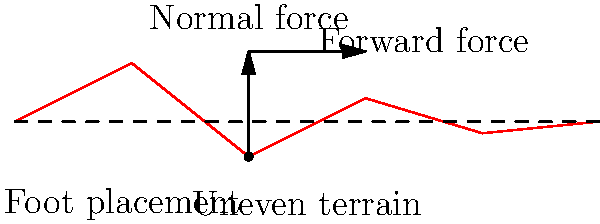When walking on uneven historical site terrain, as shown in the diagram, which biomechanical adaptation is most crucial for maintaining balance and preventing falls? To understand the biomechanical adaptation necessary for walking on uneven terrain, let's analyze the situation step-by-step:

1. Terrain characteristics: The diagram shows an uneven surface, typical of historical sites with worn or irregular pathways.

2. Foot placement: The red dot indicates where the foot is placed on a lower point of the terrain.

3. Force distribution:
   a. Normal force (vertical arrow): This represents the ground reaction force pushing up against the foot.
   b. Forward force (horizontal arrow): This represents the propulsive force needed to move forward.

4. Biomechanical challenges:
   a. Inconsistent surface height requires constant adjustment of leg length.
   b. Varying slopes affect the distribution of forces between normal and forward components.
   c. Uncertain footing increases the risk of ankle inversion or eversion.

5. Adaptation requirements:
   a. Proprioception: The ability to sense the position and movement of body parts.
   b. Ankle strategy: Rapid adjustments of ankle position to maintain balance.
   c. Hip strategy: Larger movements at the hip to shift the center of mass.
   d. Step width and length adjustments: To optimize stability on changing terrain.

6. Most crucial adaptation:
   Among these, proprioception is the most fundamental. It allows for:
   - Rapid sensing of terrain changes
   - Immediate feedback on foot placement
   - Quick activation of other strategies (ankle, hip, step adjustments)

Without accurate proprioception, other biomechanical adaptations would be less effective or too slow to prevent loss of balance and potential falls.
Answer: Proprioception 